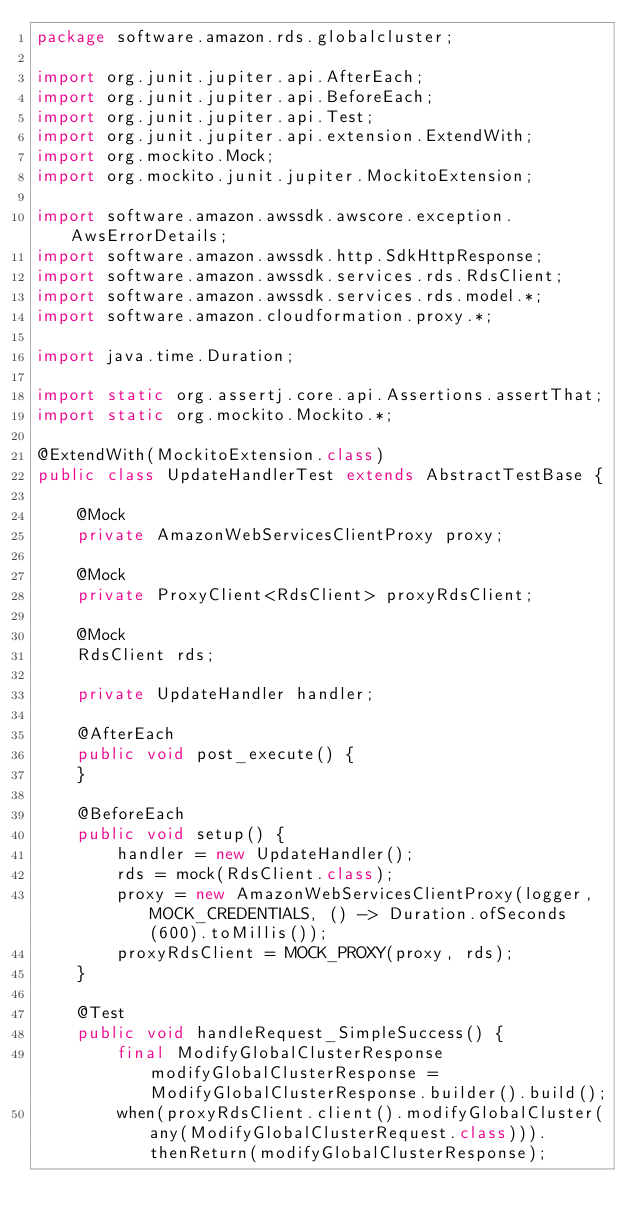Convert code to text. <code><loc_0><loc_0><loc_500><loc_500><_Java_>package software.amazon.rds.globalcluster;

import org.junit.jupiter.api.AfterEach;
import org.junit.jupiter.api.BeforeEach;
import org.junit.jupiter.api.Test;
import org.junit.jupiter.api.extension.ExtendWith;
import org.mockito.Mock;
import org.mockito.junit.jupiter.MockitoExtension;

import software.amazon.awssdk.awscore.exception.AwsErrorDetails;
import software.amazon.awssdk.http.SdkHttpResponse;
import software.amazon.awssdk.services.rds.RdsClient;
import software.amazon.awssdk.services.rds.model.*;
import software.amazon.cloudformation.proxy.*;

import java.time.Duration;

import static org.assertj.core.api.Assertions.assertThat;
import static org.mockito.Mockito.*;

@ExtendWith(MockitoExtension.class)
public class UpdateHandlerTest extends AbstractTestBase {

    @Mock
    private AmazonWebServicesClientProxy proxy;

    @Mock
    private ProxyClient<RdsClient> proxyRdsClient;

    @Mock
    RdsClient rds;

    private UpdateHandler handler;

    @AfterEach
    public void post_execute() {
    }

    @BeforeEach
    public void setup() {
        handler = new UpdateHandler();
        rds = mock(RdsClient.class);
        proxy = new AmazonWebServicesClientProxy(logger, MOCK_CREDENTIALS, () -> Duration.ofSeconds(600).toMillis());
        proxyRdsClient = MOCK_PROXY(proxy, rds);
    }

    @Test
    public void handleRequest_SimpleSuccess() {
        final ModifyGlobalClusterResponse modifyGlobalClusterResponse = ModifyGlobalClusterResponse.builder().build();
        when(proxyRdsClient.client().modifyGlobalCluster(any(ModifyGlobalClusterRequest.class))).thenReturn(modifyGlobalClusterResponse);</code> 